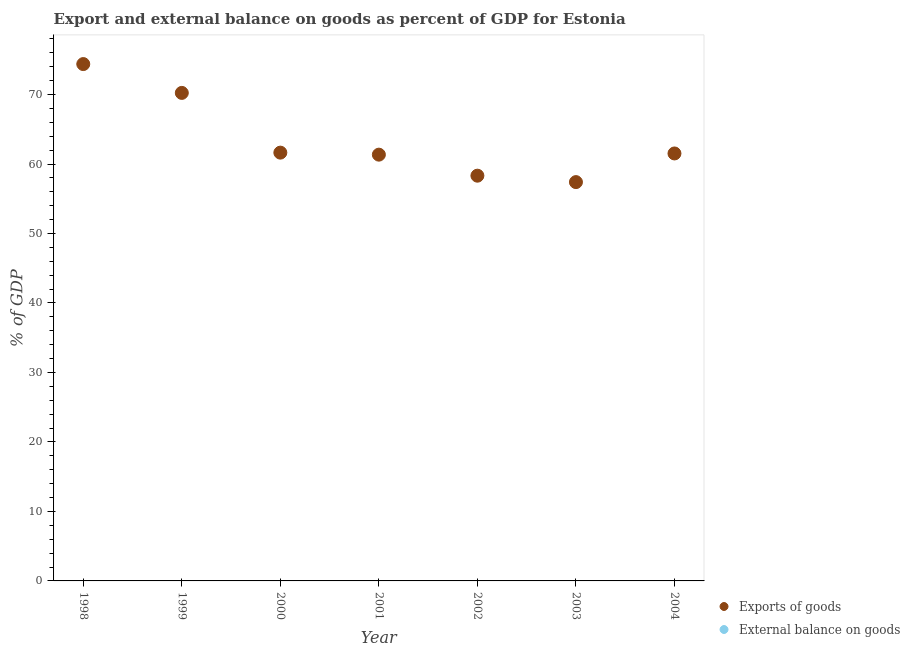Is the number of dotlines equal to the number of legend labels?
Offer a very short reply. No. What is the external balance on goods as percentage of gdp in 2004?
Keep it short and to the point. 0. Across all years, what is the maximum export of goods as percentage of gdp?
Ensure brevity in your answer.  74.38. Across all years, what is the minimum external balance on goods as percentage of gdp?
Provide a succinct answer. 0. What is the difference between the export of goods as percentage of gdp in 2001 and that in 2004?
Offer a very short reply. -0.17. What is the difference between the export of goods as percentage of gdp in 1999 and the external balance on goods as percentage of gdp in 1998?
Your answer should be compact. 70.23. What is the average export of goods as percentage of gdp per year?
Give a very brief answer. 63.55. In how many years, is the export of goods as percentage of gdp greater than 48 %?
Provide a short and direct response. 7. What is the ratio of the export of goods as percentage of gdp in 1998 to that in 2001?
Keep it short and to the point. 1.21. Is the export of goods as percentage of gdp in 2002 less than that in 2004?
Provide a short and direct response. Yes. What is the difference between the highest and the second highest export of goods as percentage of gdp?
Keep it short and to the point. 4.15. What is the difference between the highest and the lowest export of goods as percentage of gdp?
Offer a very short reply. 16.99. Is the sum of the export of goods as percentage of gdp in 1998 and 2000 greater than the maximum external balance on goods as percentage of gdp across all years?
Make the answer very short. Yes. Is the export of goods as percentage of gdp strictly less than the external balance on goods as percentage of gdp over the years?
Your response must be concise. No. How many years are there in the graph?
Provide a short and direct response. 7. What is the difference between two consecutive major ticks on the Y-axis?
Your response must be concise. 10. Does the graph contain grids?
Keep it short and to the point. No. Where does the legend appear in the graph?
Make the answer very short. Bottom right. How many legend labels are there?
Ensure brevity in your answer.  2. What is the title of the graph?
Offer a very short reply. Export and external balance on goods as percent of GDP for Estonia. Does "Merchandise exports" appear as one of the legend labels in the graph?
Offer a terse response. No. What is the label or title of the Y-axis?
Your answer should be compact. % of GDP. What is the % of GDP in Exports of goods in 1998?
Make the answer very short. 74.38. What is the % of GDP in External balance on goods in 1998?
Make the answer very short. 0. What is the % of GDP of Exports of goods in 1999?
Offer a terse response. 70.23. What is the % of GDP in Exports of goods in 2000?
Give a very brief answer. 61.64. What is the % of GDP in External balance on goods in 2000?
Offer a very short reply. 0. What is the % of GDP of Exports of goods in 2001?
Make the answer very short. 61.35. What is the % of GDP in Exports of goods in 2002?
Your answer should be very brief. 58.32. What is the % of GDP of Exports of goods in 2003?
Provide a short and direct response. 57.4. What is the % of GDP in Exports of goods in 2004?
Ensure brevity in your answer.  61.52. Across all years, what is the maximum % of GDP in Exports of goods?
Provide a short and direct response. 74.38. Across all years, what is the minimum % of GDP of Exports of goods?
Keep it short and to the point. 57.4. What is the total % of GDP of Exports of goods in the graph?
Offer a very short reply. 444.83. What is the difference between the % of GDP in Exports of goods in 1998 and that in 1999?
Your response must be concise. 4.15. What is the difference between the % of GDP of Exports of goods in 1998 and that in 2000?
Provide a short and direct response. 12.75. What is the difference between the % of GDP of Exports of goods in 1998 and that in 2001?
Give a very brief answer. 13.04. What is the difference between the % of GDP in Exports of goods in 1998 and that in 2002?
Keep it short and to the point. 16.06. What is the difference between the % of GDP in Exports of goods in 1998 and that in 2003?
Offer a terse response. 16.99. What is the difference between the % of GDP of Exports of goods in 1998 and that in 2004?
Your response must be concise. 12.86. What is the difference between the % of GDP in Exports of goods in 1999 and that in 2000?
Offer a terse response. 8.6. What is the difference between the % of GDP in Exports of goods in 1999 and that in 2001?
Ensure brevity in your answer.  8.89. What is the difference between the % of GDP of Exports of goods in 1999 and that in 2002?
Your response must be concise. 11.91. What is the difference between the % of GDP of Exports of goods in 1999 and that in 2003?
Ensure brevity in your answer.  12.84. What is the difference between the % of GDP of Exports of goods in 1999 and that in 2004?
Ensure brevity in your answer.  8.71. What is the difference between the % of GDP in Exports of goods in 2000 and that in 2001?
Keep it short and to the point. 0.29. What is the difference between the % of GDP in Exports of goods in 2000 and that in 2002?
Offer a very short reply. 3.32. What is the difference between the % of GDP in Exports of goods in 2000 and that in 2003?
Your response must be concise. 4.24. What is the difference between the % of GDP of Exports of goods in 2000 and that in 2004?
Make the answer very short. 0.12. What is the difference between the % of GDP in Exports of goods in 2001 and that in 2002?
Give a very brief answer. 3.03. What is the difference between the % of GDP in Exports of goods in 2001 and that in 2003?
Give a very brief answer. 3.95. What is the difference between the % of GDP of Exports of goods in 2001 and that in 2004?
Your response must be concise. -0.17. What is the difference between the % of GDP in Exports of goods in 2002 and that in 2003?
Offer a very short reply. 0.92. What is the difference between the % of GDP of Exports of goods in 2002 and that in 2004?
Offer a terse response. -3.2. What is the difference between the % of GDP of Exports of goods in 2003 and that in 2004?
Offer a terse response. -4.12. What is the average % of GDP in Exports of goods per year?
Your answer should be compact. 63.55. What is the average % of GDP of External balance on goods per year?
Provide a succinct answer. 0. What is the ratio of the % of GDP of Exports of goods in 1998 to that in 1999?
Offer a terse response. 1.06. What is the ratio of the % of GDP in Exports of goods in 1998 to that in 2000?
Provide a succinct answer. 1.21. What is the ratio of the % of GDP of Exports of goods in 1998 to that in 2001?
Ensure brevity in your answer.  1.21. What is the ratio of the % of GDP in Exports of goods in 1998 to that in 2002?
Your response must be concise. 1.28. What is the ratio of the % of GDP in Exports of goods in 1998 to that in 2003?
Provide a succinct answer. 1.3. What is the ratio of the % of GDP of Exports of goods in 1998 to that in 2004?
Keep it short and to the point. 1.21. What is the ratio of the % of GDP of Exports of goods in 1999 to that in 2000?
Keep it short and to the point. 1.14. What is the ratio of the % of GDP of Exports of goods in 1999 to that in 2001?
Give a very brief answer. 1.14. What is the ratio of the % of GDP in Exports of goods in 1999 to that in 2002?
Provide a succinct answer. 1.2. What is the ratio of the % of GDP in Exports of goods in 1999 to that in 2003?
Offer a terse response. 1.22. What is the ratio of the % of GDP in Exports of goods in 1999 to that in 2004?
Keep it short and to the point. 1.14. What is the ratio of the % of GDP of Exports of goods in 2000 to that in 2001?
Keep it short and to the point. 1. What is the ratio of the % of GDP in Exports of goods in 2000 to that in 2002?
Provide a succinct answer. 1.06. What is the ratio of the % of GDP of Exports of goods in 2000 to that in 2003?
Offer a terse response. 1.07. What is the ratio of the % of GDP of Exports of goods in 2001 to that in 2002?
Give a very brief answer. 1.05. What is the ratio of the % of GDP of Exports of goods in 2001 to that in 2003?
Give a very brief answer. 1.07. What is the ratio of the % of GDP of Exports of goods in 2001 to that in 2004?
Offer a very short reply. 1. What is the ratio of the % of GDP in Exports of goods in 2002 to that in 2003?
Make the answer very short. 1.02. What is the ratio of the % of GDP in Exports of goods in 2002 to that in 2004?
Offer a very short reply. 0.95. What is the ratio of the % of GDP of Exports of goods in 2003 to that in 2004?
Your answer should be very brief. 0.93. What is the difference between the highest and the second highest % of GDP of Exports of goods?
Provide a succinct answer. 4.15. What is the difference between the highest and the lowest % of GDP in Exports of goods?
Ensure brevity in your answer.  16.99. 